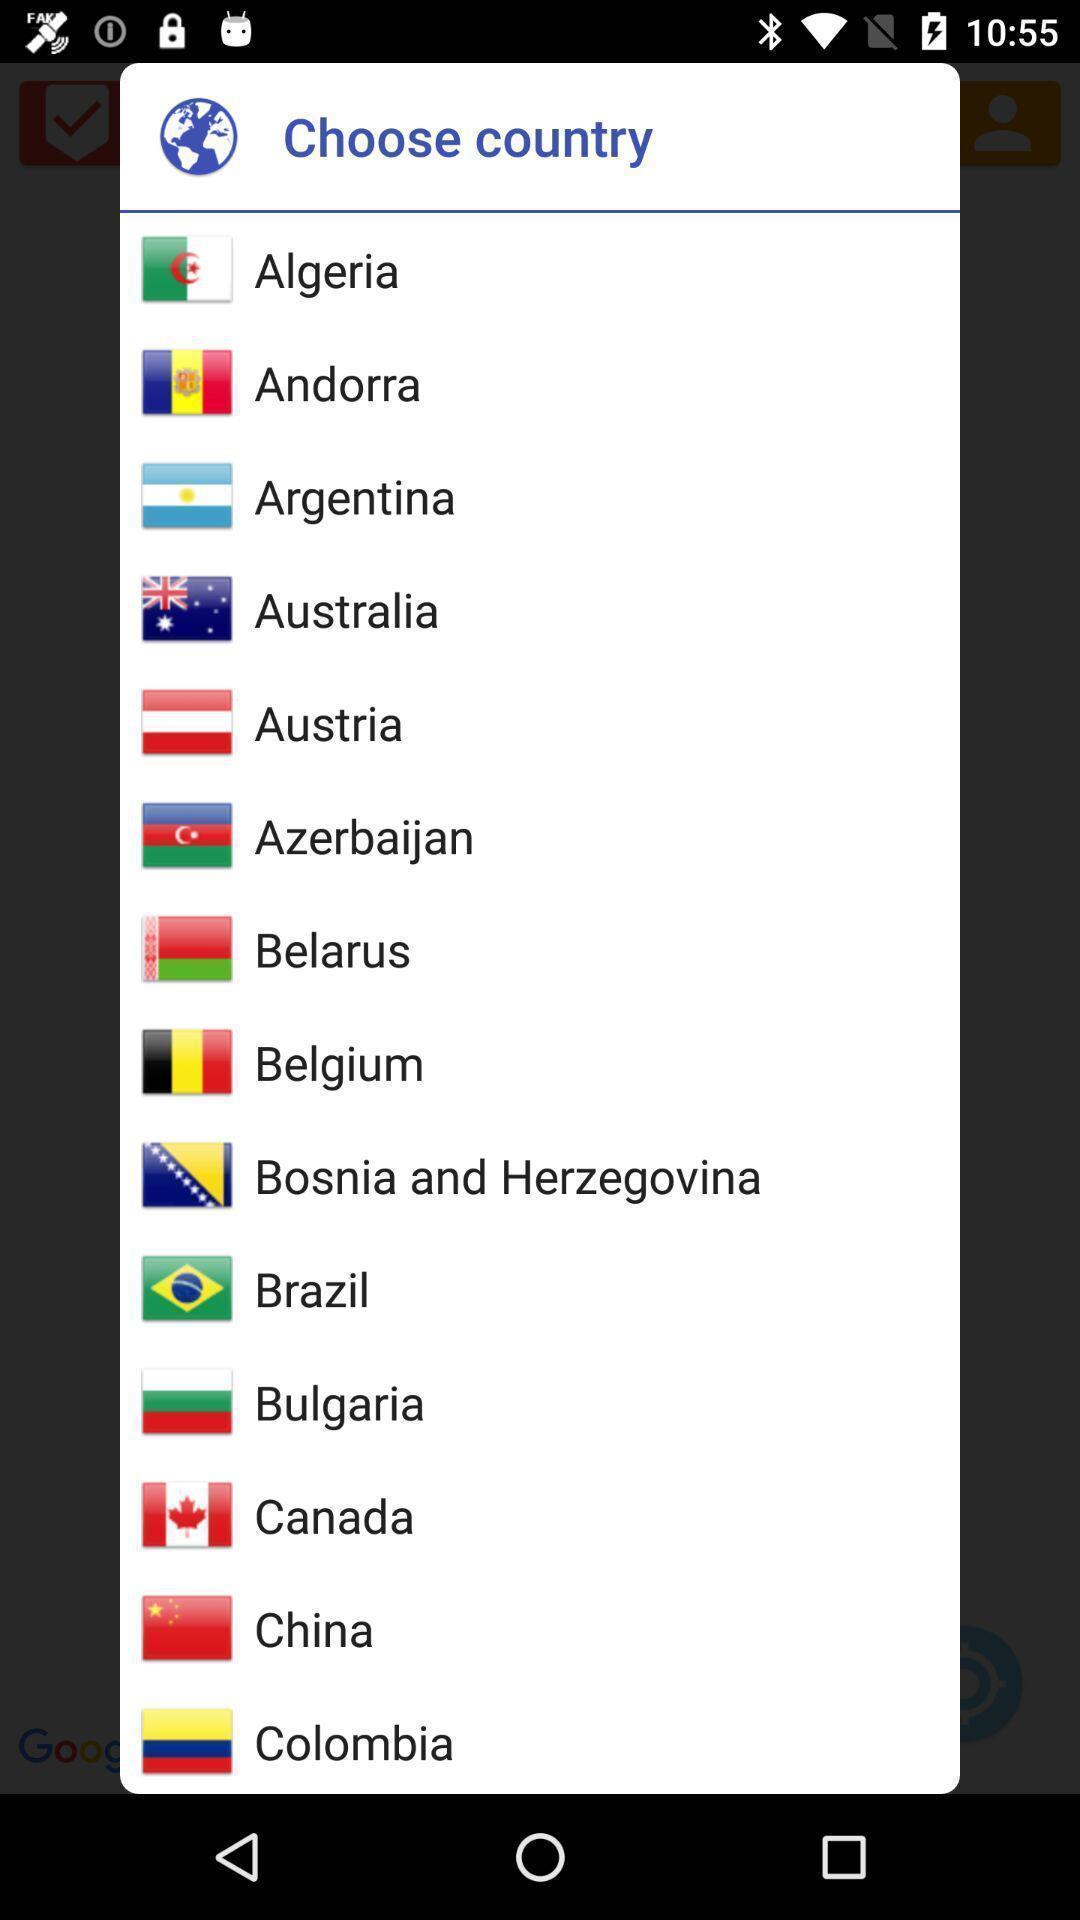Provide a textual representation of this image. Popup showing different countries to choose. 